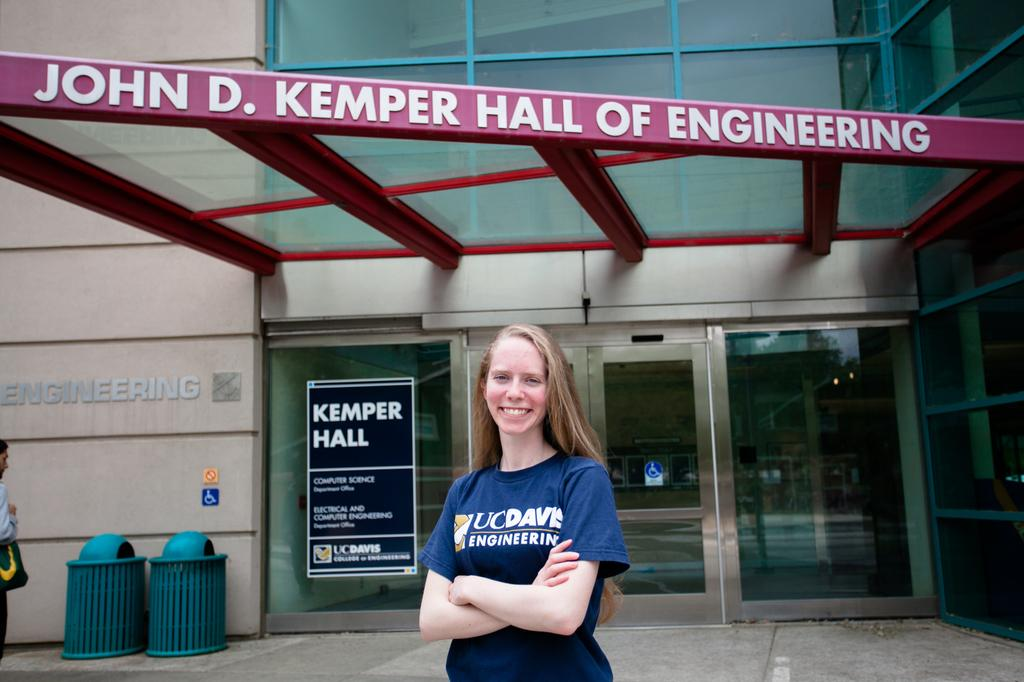<image>
Create a compact narrative representing the image presented. A woman is standing in front of the Kemper Hall of Engineering. 